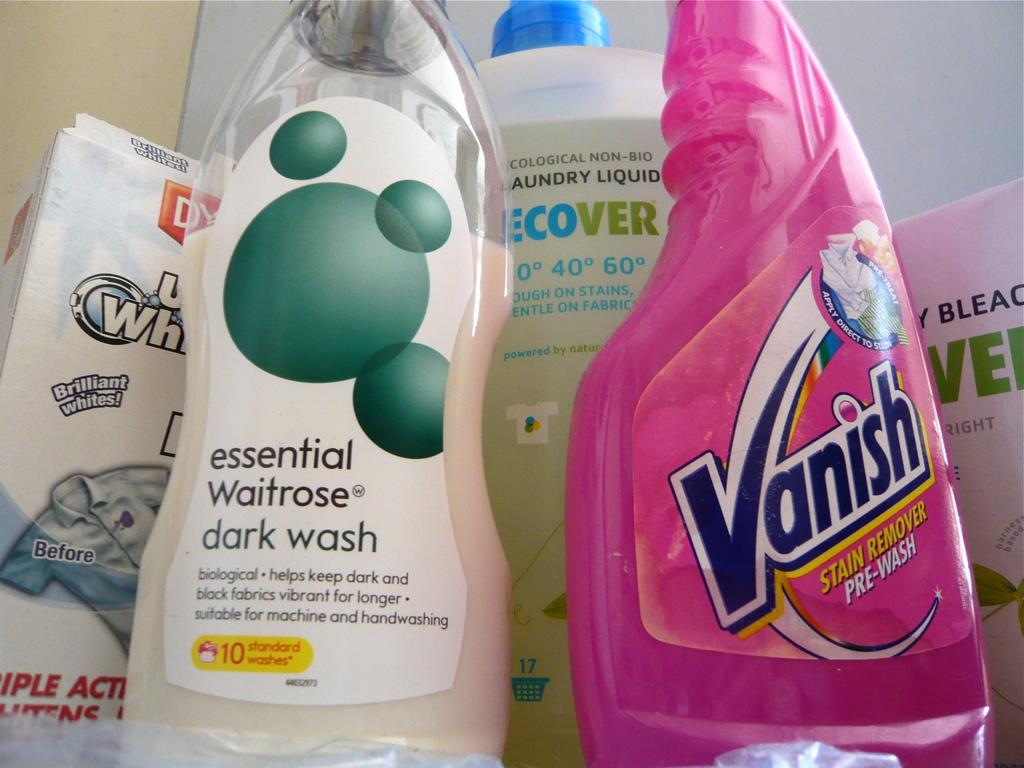<image>
Provide a brief description of the given image. A bottle of Vanish sitting next to a bottle of Waitrose dark wash. 